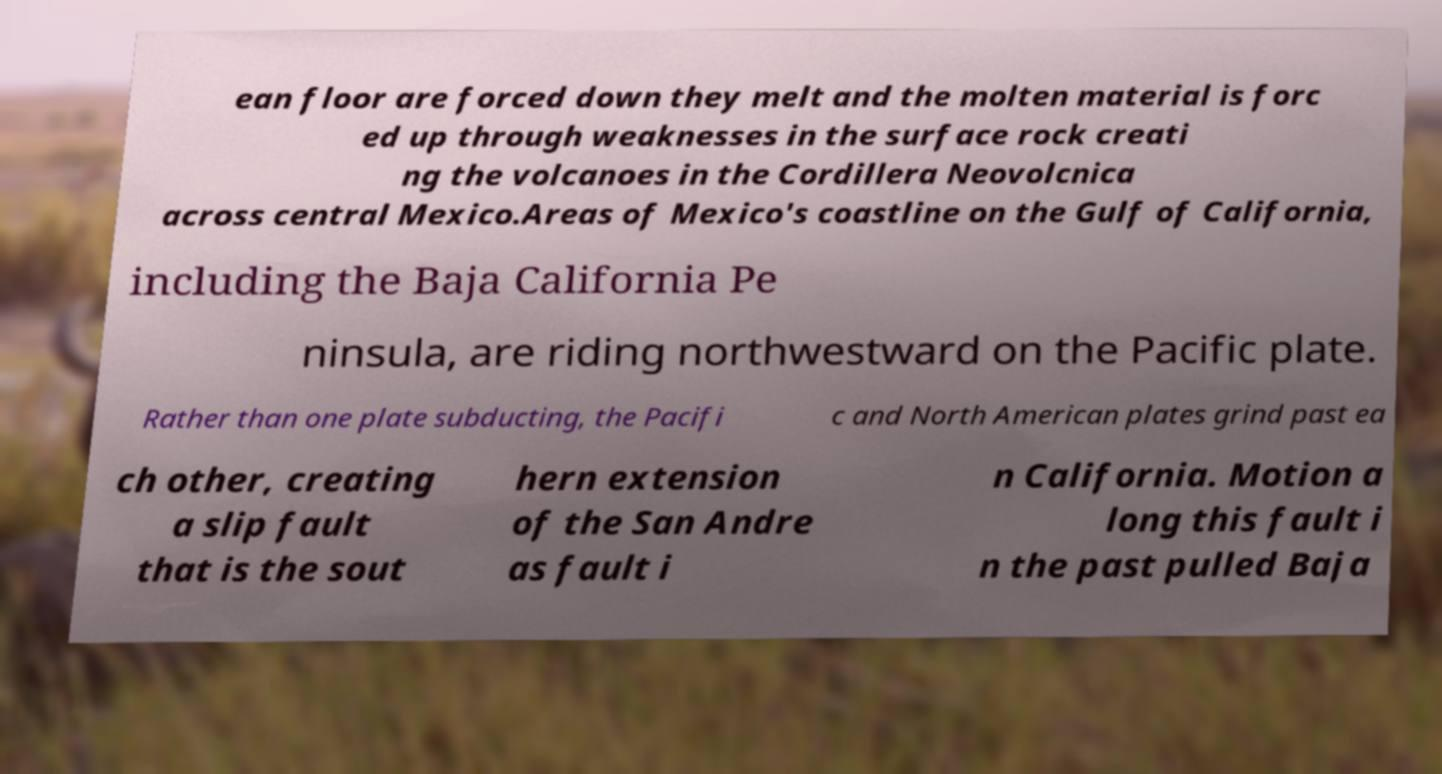Could you assist in decoding the text presented in this image and type it out clearly? ean floor are forced down they melt and the molten material is forc ed up through weaknesses in the surface rock creati ng the volcanoes in the Cordillera Neovolcnica across central Mexico.Areas of Mexico's coastline on the Gulf of California, including the Baja California Pe ninsula, are riding northwestward on the Pacific plate. Rather than one plate subducting, the Pacifi c and North American plates grind past ea ch other, creating a slip fault that is the sout hern extension of the San Andre as fault i n California. Motion a long this fault i n the past pulled Baja 